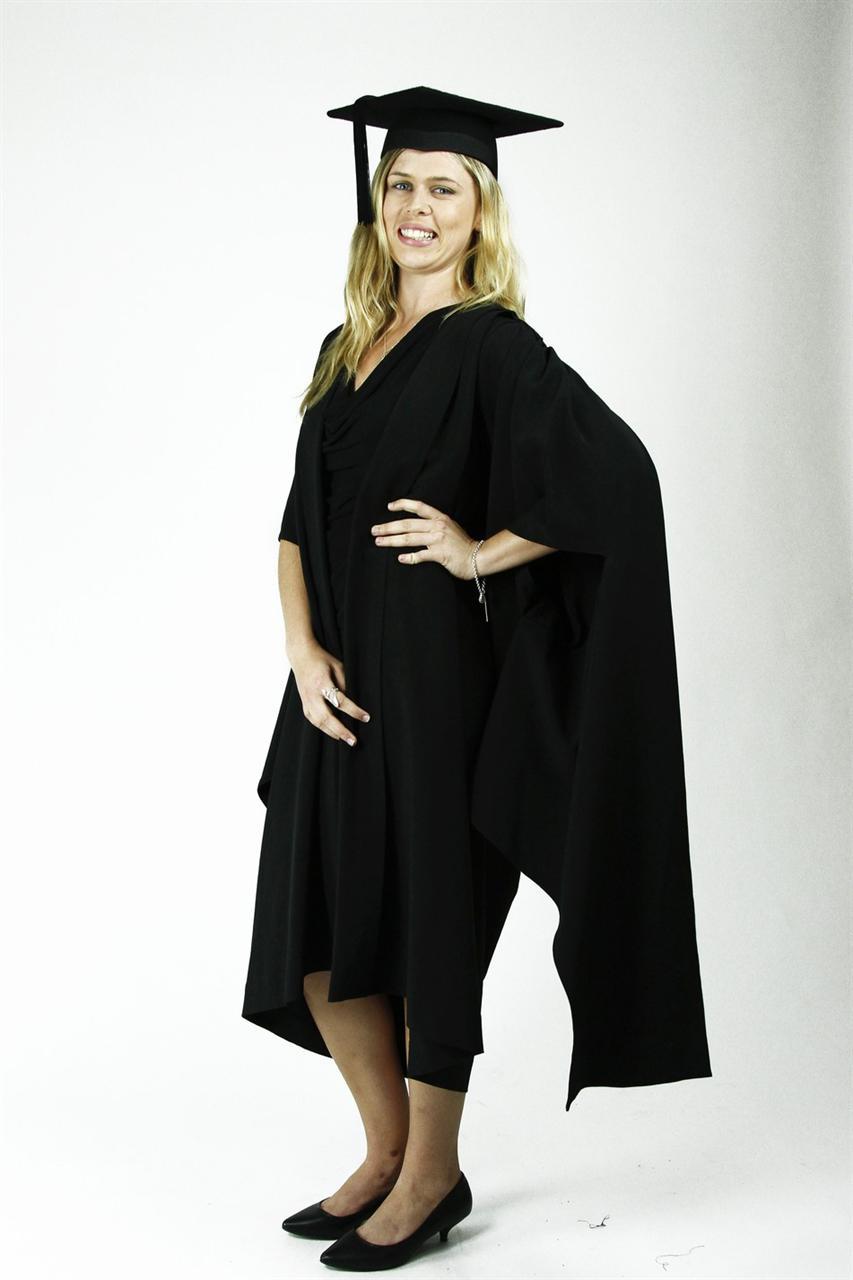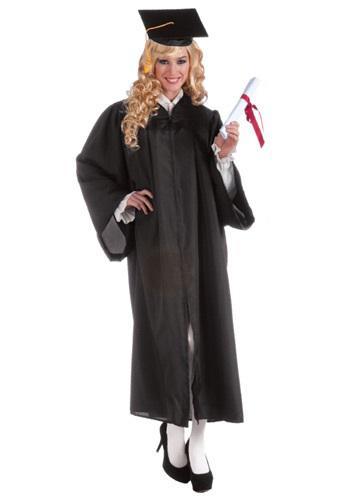The first image is the image on the left, the second image is the image on the right. Assess this claim about the two images: "There are two women in graduation clothes facing the camera.". Correct or not? Answer yes or no. Yes. 